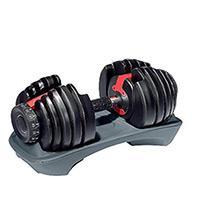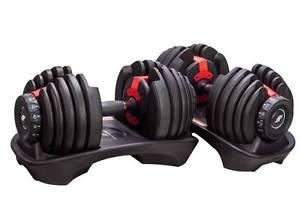The first image is the image on the left, the second image is the image on the right. Considering the images on both sides, is "The combined images include three dumbbell bars with weights on each end." valid? Answer yes or no. Yes. The first image is the image on the left, the second image is the image on the right. Given the left and right images, does the statement "The left and right image contains a total of three dumbbells." hold true? Answer yes or no. Yes. 